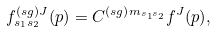<formula> <loc_0><loc_0><loc_500><loc_500>f _ { s _ { 1 } s _ { 2 } } ^ { \left ( s g \right ) J } ( p ) = C ^ { \left ( s g \right ) m _ { s _ { 1 } s _ { 2 } } } f ^ { J } ( p ) ,</formula> 